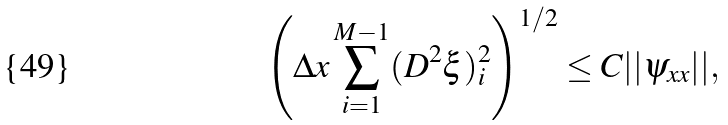<formula> <loc_0><loc_0><loc_500><loc_500>\left ( \Delta x \sum _ { i = 1 } ^ { M - 1 } ( D ^ { 2 } \xi ) _ { i } ^ { 2 } \right ) ^ { 1 / 2 } \leq C | | \psi _ { x x } | | ,</formula> 